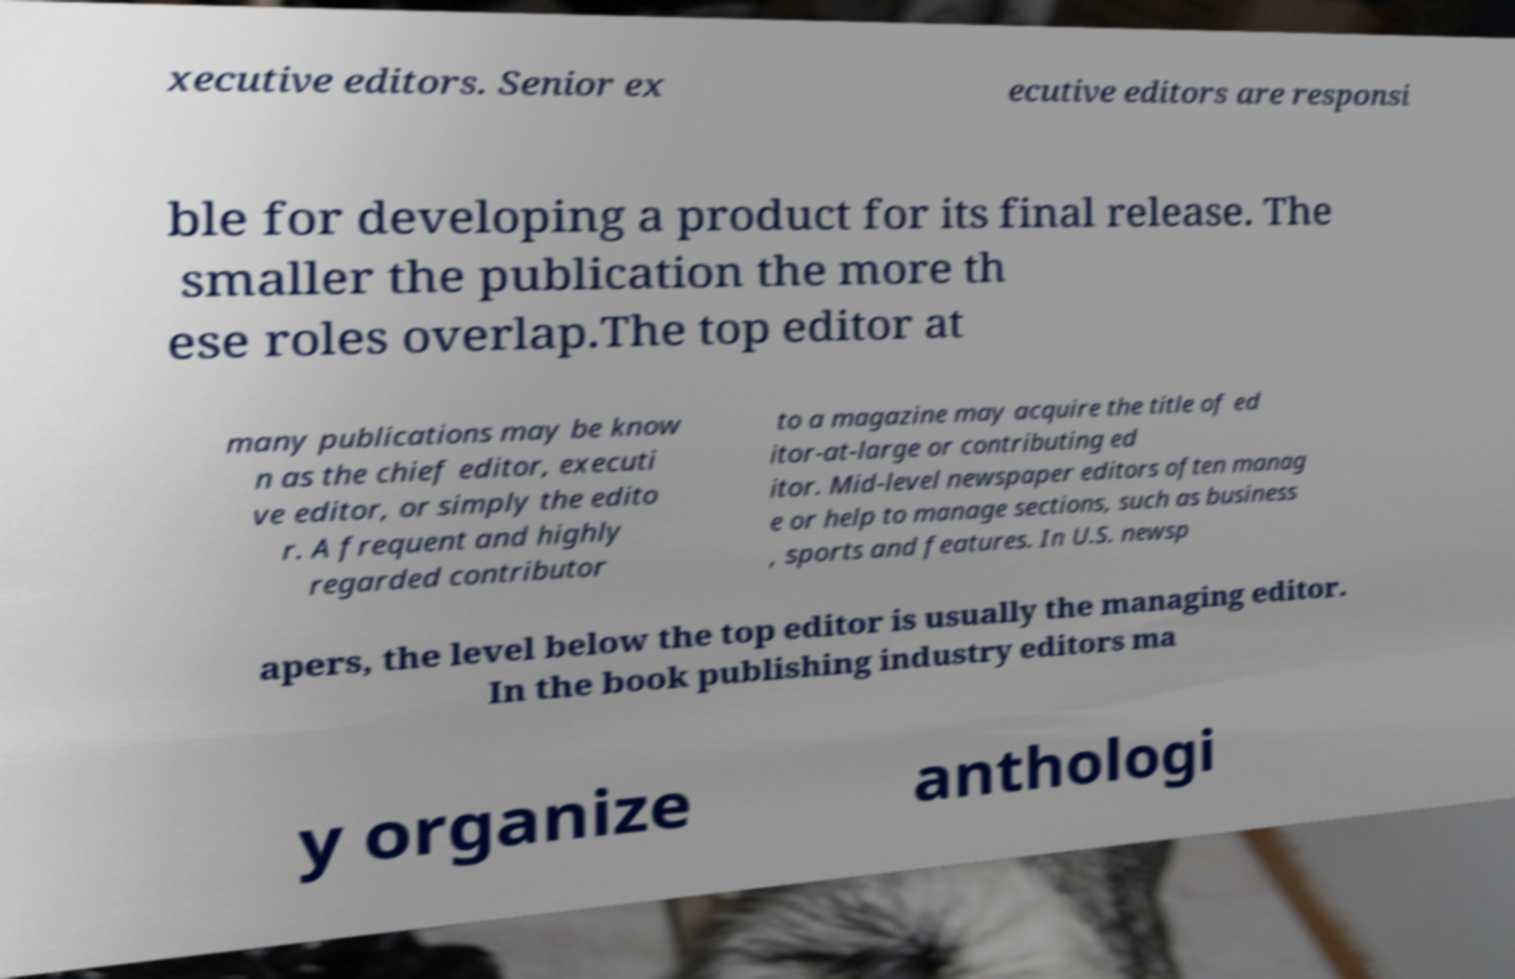Please identify and transcribe the text found in this image. xecutive editors. Senior ex ecutive editors are responsi ble for developing a product for its final release. The smaller the publication the more th ese roles overlap.The top editor at many publications may be know n as the chief editor, executi ve editor, or simply the edito r. A frequent and highly regarded contributor to a magazine may acquire the title of ed itor-at-large or contributing ed itor. Mid-level newspaper editors often manag e or help to manage sections, such as business , sports and features. In U.S. newsp apers, the level below the top editor is usually the managing editor. In the book publishing industry editors ma y organize anthologi 